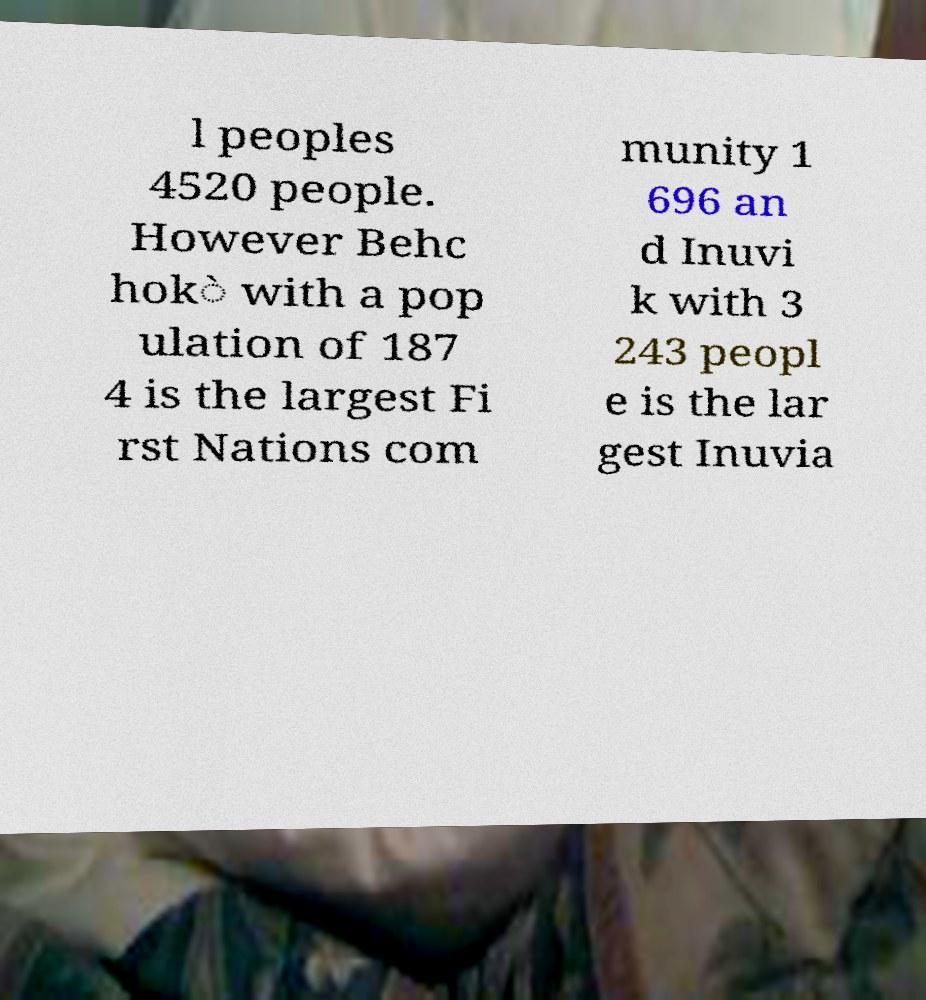There's text embedded in this image that I need extracted. Can you transcribe it verbatim? l peoples 4520 people. However Behc hok̀ with a pop ulation of 187 4 is the largest Fi rst Nations com munity 1 696 an d Inuvi k with 3 243 peopl e is the lar gest Inuvia 